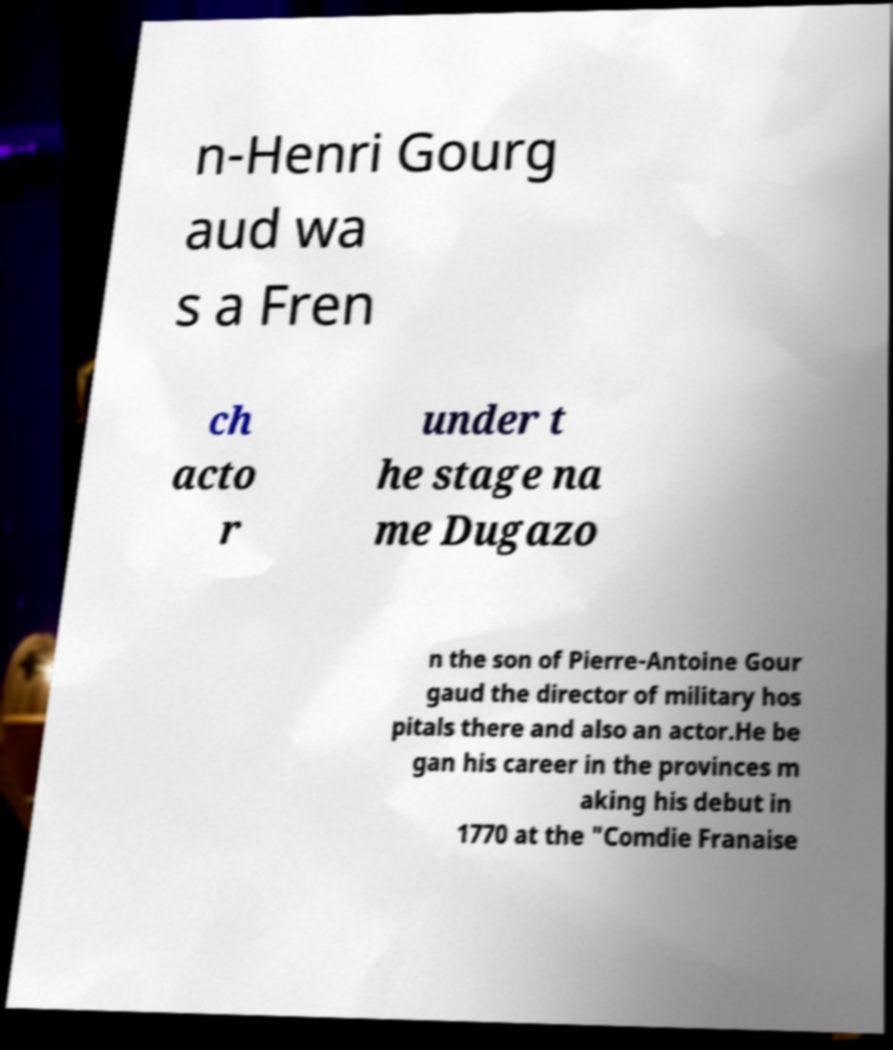Please identify and transcribe the text found in this image. n-Henri Gourg aud wa s a Fren ch acto r under t he stage na me Dugazo n the son of Pierre-Antoine Gour gaud the director of military hos pitals there and also an actor.He be gan his career in the provinces m aking his debut in 1770 at the "Comdie Franaise 